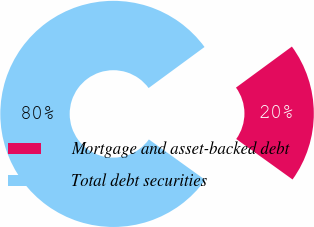Convert chart. <chart><loc_0><loc_0><loc_500><loc_500><pie_chart><fcel>Mortgage and asset-backed debt<fcel>Total debt securities<nl><fcel>20.0%<fcel>80.0%<nl></chart> 